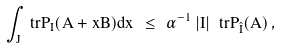Convert formula to latex. <formula><loc_0><loc_0><loc_500><loc_500>\int _ { J } \ t r P _ { I } ( A + x B ) d x \ \leq \ \alpha ^ { - 1 } \, | I | \, \ t r P _ { \hat { I } } ( A ) \, ,</formula> 